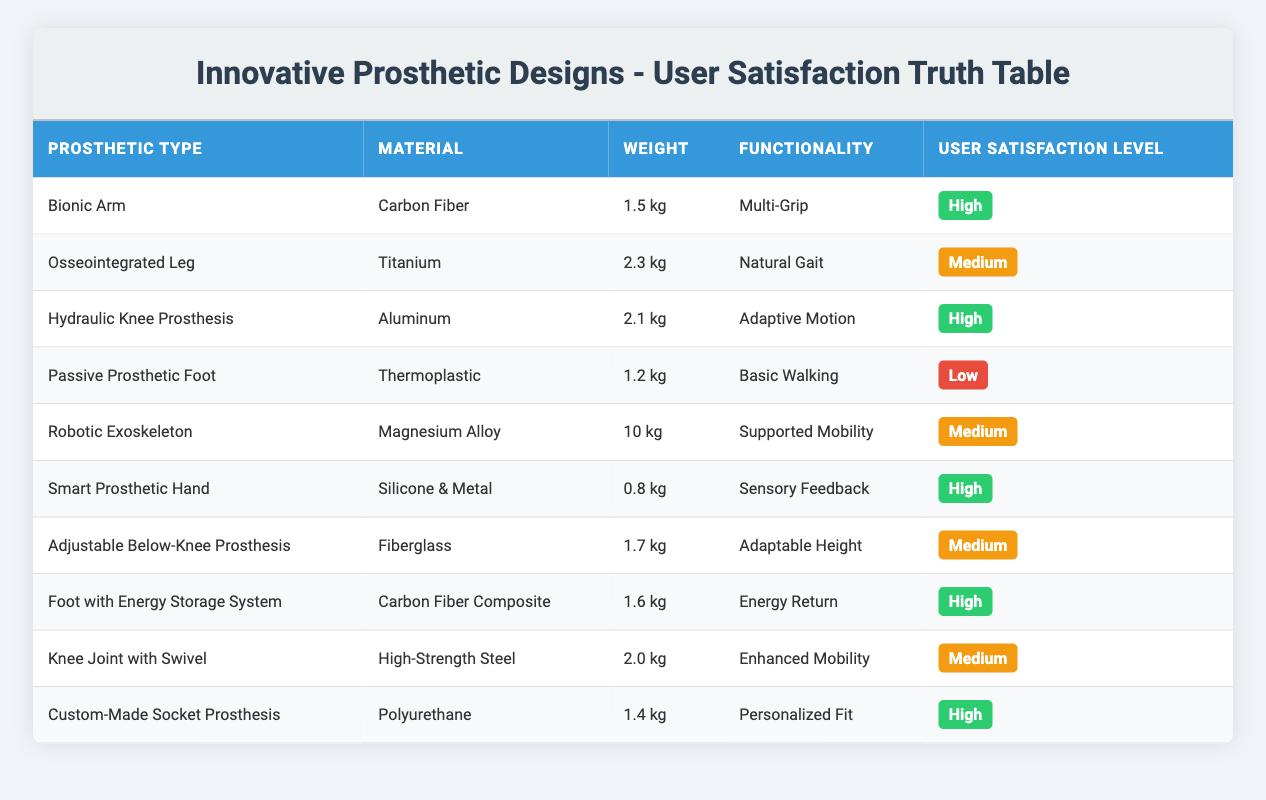What is the user satisfaction level of the Bionic Arm? The user satisfaction level for the Bionic Arm is listed in the table under "User Satisfaction Level". It shows "High".
Answer: High Which prosthetic type is made from Silicone & Metal? In the table, there is only one prosthetic type listed that is made from Silicone & Metal, which is the Smart Prosthetic Hand.
Answer: Smart Prosthetic Hand How many prosthetic types have a user satisfaction level labeled as Medium? By counting the number of occurrences of "Medium" in the "User Satisfaction Level" column, we find three types: Osseointegrated Leg, Robotic Exoskeleton, and Adjustable Below-Knee Prosthesis.
Answer: 3 Is the Passive Prosthetic Foot the lightest prosthetic type listed? The table shows a weight of 1.2 kg for the Passive Prosthetic Foot, which is lighter compared to others such as the Smart Prosthetic Hand (0.8 kg), making it incorrect to say it's the lightest.
Answer: No What is the total weight of all high user satisfaction prosthetics combined? The weights of the high user satisfaction prosthetics are: Bionic Arm (1.5 kg), Hydraulic Knee Prosthesis (2.1 kg), Smart Prosthetic Hand (0.8 kg), Foot with Energy Storage System (1.6 kg), and Custom-Made Socket Prosthesis (1.4 kg). The total weight is 1.5 + 2.1 + 0.8 + 1.6 + 1.4 = 7.4 kg.
Answer: 7.4 kg Which prosthetic type has the highest user satisfaction level and what is its weight? The table indicates that the Bionic Arm, Smart Prosthetic Hand, Foot with Energy Storage System, and Custom-Made Socket Prosthesis all have a user satisfaction level of High. Among them, the Bionic Arm weighs 1.5 kg, the Smart Prosthetic Hand weighs 0.8 kg, the Foot with Energy Storage System weighs 1.6 kg, and the Custom-Made Socket Prosthesis weighs 1.4 kg. The highest user satisfaction level is shared by these types, thus the Bionic Arm is one of the correct answers.
Answer: 1.5 kg Do all prosthetic designs made from carbon fiber have high user satisfaction? The only two prosthetics made from carbon fiber are the Bionic Arm (satisfaction level: High) and Foot with Energy Storage System (satisfaction level: High). Thus, they do have high user satisfaction, confirming the assertion to be correct.
Answer: Yes Which type of prosthetic has the functionality of Energy Return? The table clearly states that the Foot with Energy Storage System has the functionality of Energy Return.
Answer: Foot with Energy Storage System 